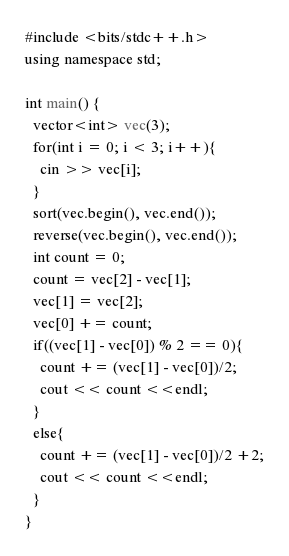<code> <loc_0><loc_0><loc_500><loc_500><_Java_>#include <bits/stdc++.h>
using namespace std;

int main() {
  vector<int> vec(3);
  for(int i = 0; i < 3; i++){
    cin >> vec[i];
  }
  sort(vec.begin(), vec.end());
  reverse(vec.begin(), vec.end());
  int count = 0;
  count = vec[2] - vec[1];
  vec[1] = vec[2];
  vec[0] += count;
  if((vec[1] - vec[0]) % 2 == 0){
    count += (vec[1] - vec[0])/2;
    cout << count <<endl;
  }
  else{
    count += (vec[1] - vec[0])/2 +2;
    cout << count <<endl;
  }
}
</code> 